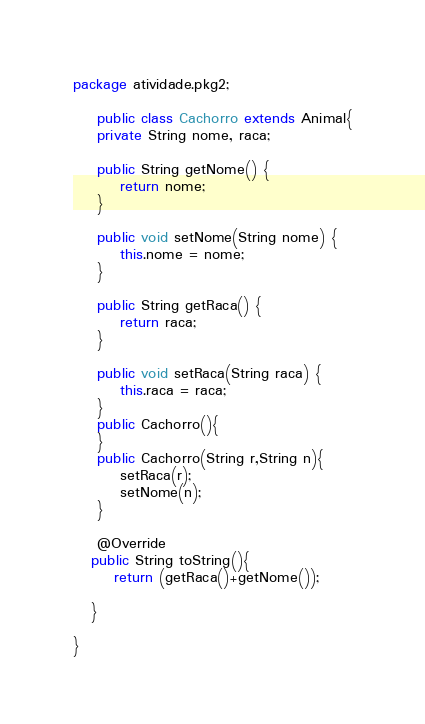Convert code to text. <code><loc_0><loc_0><loc_500><loc_500><_Java_>package atividade.pkg2;

    public class Cachorro extends Animal{
    private String nome, raca;

    public String getNome() {
        return nome;
    }

    public void setNome(String nome) {
        this.nome = nome;
    }

    public String getRaca() {
        return raca;
    }

    public void setRaca(String raca) {
        this.raca = raca;
    }
    public Cachorro(){
    }
    public Cachorro(String r,String n){
        setRaca(r);
        setNome(n);
    }

    @Override
   public String toString(){
       return (getRaca()+getNome());

   }     
    
}

</code> 